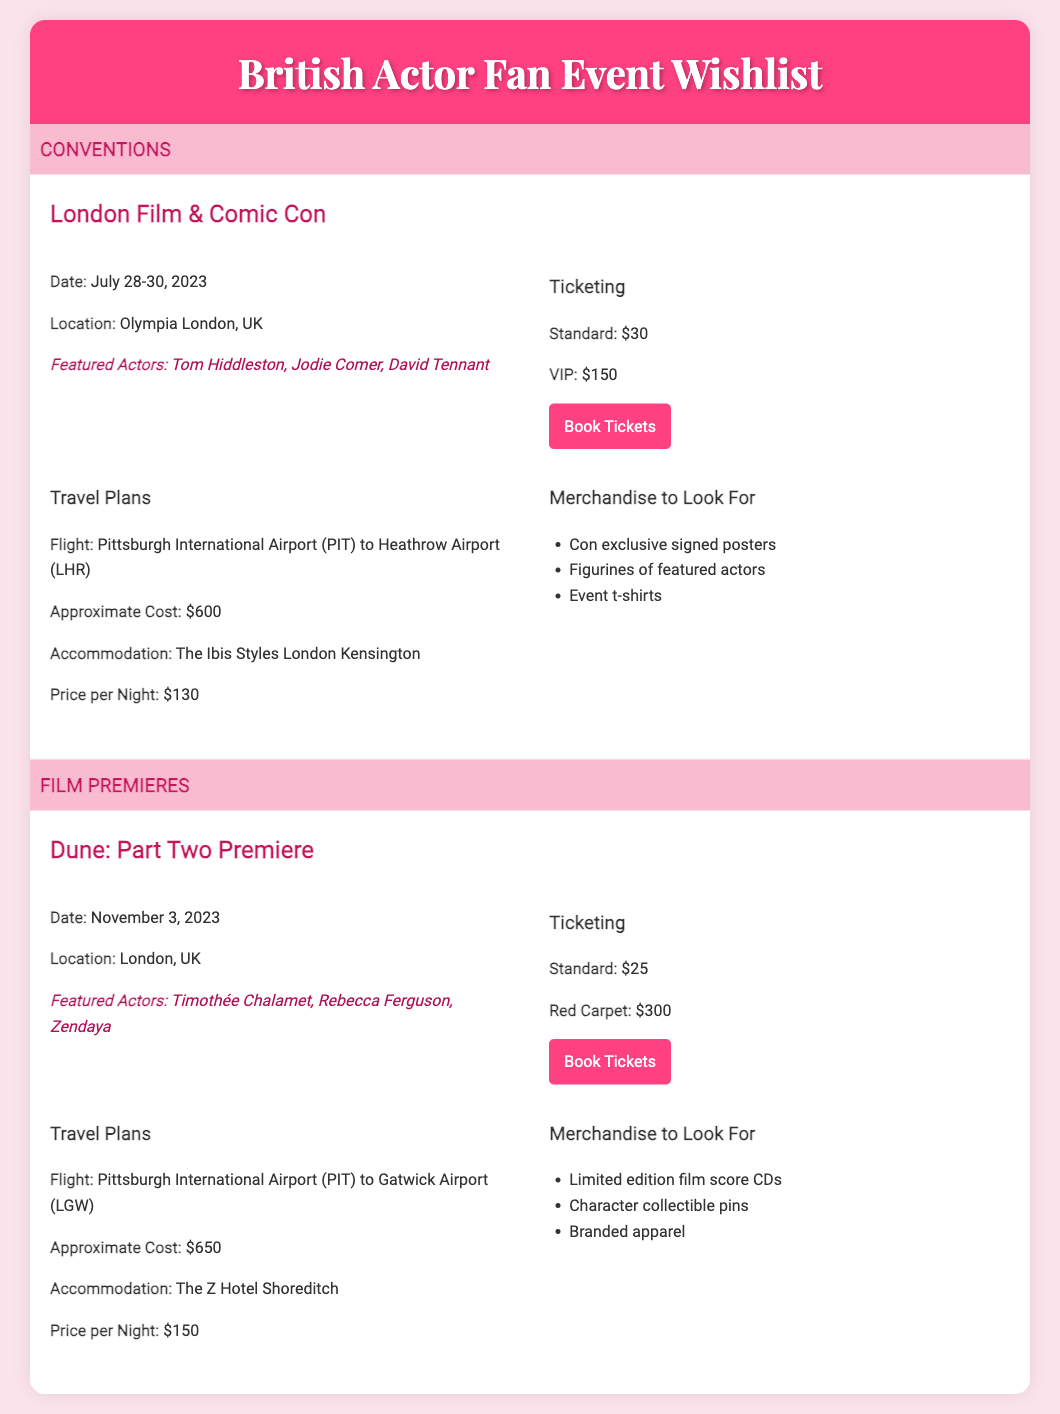what are the dates for the London Film & Comic Con? The date for the London Film & Comic Con can be found in the document, listed as July 28-30, 2023.
Answer: July 28-30, 2023 where is the Dune: Part Two Premiere taking place? The location of the Dune: Part Two Premiere is mentioned, and it is London, UK.
Answer: London, UK how much does a VIP ticket cost for London Film & Comic Con? The price for a VIP ticket is provided in the ticketing section, which states it is $150.
Answer: $150 what type of merchandise can be found at the London Film & Comic Con? The merchandise section lists items available, including signed posters, figurines, and event t-shirts.
Answer: Con exclusive signed posters, figurines of featured actors, event t-shirts which actor is featured at both events? The document lists the featured actors, and Tom Hiddleston is specific to the conventions but not found in the film premiere, while Timothée Chalamet is exclusive to Dune. No shared actors.
Answer: None what is the approximate flight cost from Pittsburgh to Gatwick Airport? The approximate cost for a flight to Gatwick Airport is mentioned in this section, which is $650.
Answer: $650 how much is the Red Carpet ticket for the Dune: Part Two Premiere? The Red Carpet ticket pricing is clearly stated in the document as $300.
Answer: $300 what hotel is recommended for accommodation during the London Film & Comic Con? The accommodation suggestion is included in the travel plans, identifying The Ibis Styles London Kensington.
Answer: The Ibis Styles London Kensington 